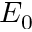<formula> <loc_0><loc_0><loc_500><loc_500>E _ { 0 }</formula> 